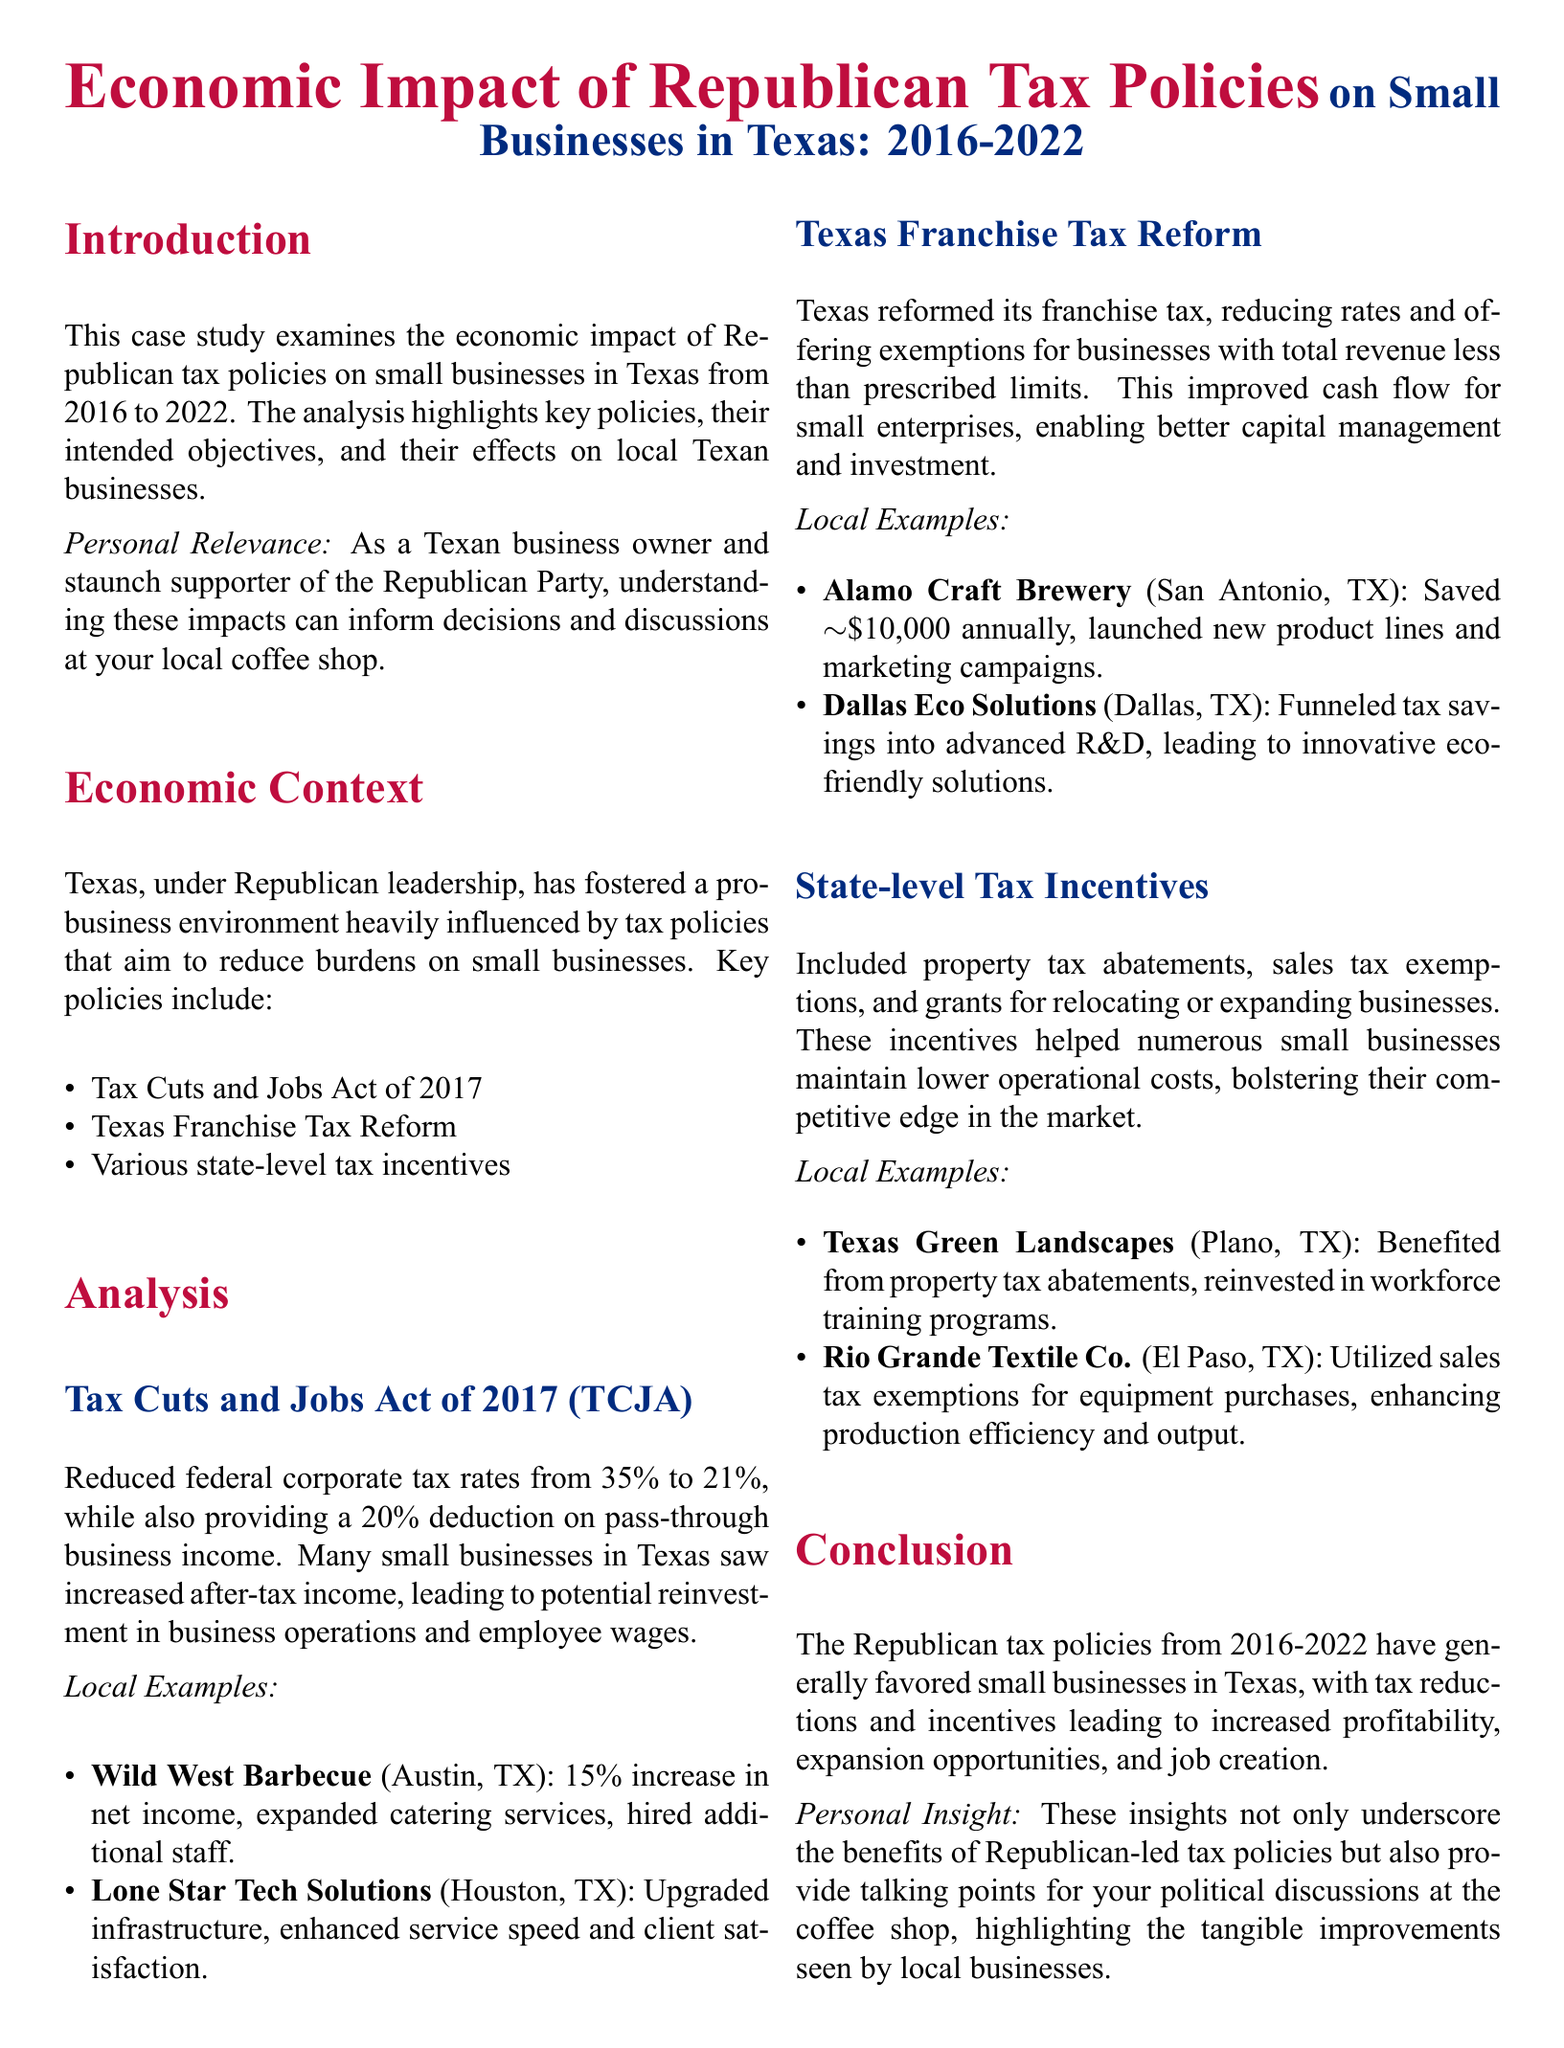What was the federal corporate tax rate before the TCJA? The federal corporate tax rate before the TCJA was 35%.
Answer: 35% What deduction did the TCJA provide for pass-through business income? The TCJA provided a 20% deduction on pass-through business income.
Answer: 20% Which Texas business saved approximately $10,000 annually due to tax reform? Alamo Craft Brewery saved approximately $10,000 annually due to tax reform.
Answer: Alamo Craft Brewery What effect did the Texas Franchise Tax Reform have on cash flow for small businesses? The Texas Franchise Tax Reform improved cash flow for small enterprises.
Answer: Improved cash flow What was the primary goal of the Republican tax policies from 2016 to 2022? The primary goal was to favor small businesses in Texas.
Answer: Favor small businesses Which two businesses expanded services or products due to tax policy benefits? Wild West Barbecue and Alamo Craft Brewery expanded services or products.
Answer: Wild West Barbecue, Alamo Craft Brewery How did Republican tax policies generally affect profitability and job creation? Republican tax policies generally led to increased profitability and job creation.
Answer: Increased profitability and job creation What type of document is this analysis? This analysis is a case study.
Answer: Case study 